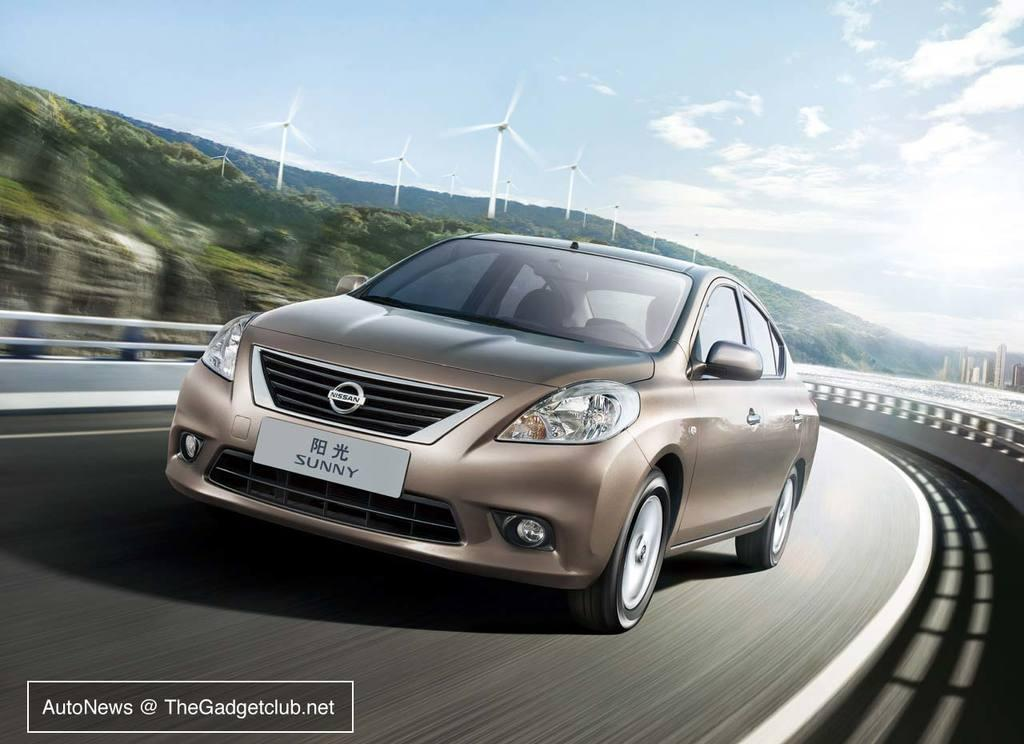What is the main subject of the image? The main subject of the image is a car. What is the car doing in the image? The car is moving on the road in the image. What can be seen in the background of the image? There is a forest in the background of the image. What other objects are present in the image? Turbines are present in the image. How would you describe the sky in the image? The sky is blue with clouds in the image. Can you hear the bell ringing in the image? There is no bell present in the image, so it cannot be heard. Is there a hospital visible in the image? There is no hospital visible in the image. How many babies are present in the image? There are no babies present in the image. 